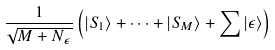Convert formula to latex. <formula><loc_0><loc_0><loc_500><loc_500>\frac { 1 } { \sqrt { M + N _ { \epsilon } } } \left ( { \left | S _ { 1 } \right > } + \cdots + { \left | S _ { M } \right > } + \sum \left | \epsilon \right > \right )</formula> 